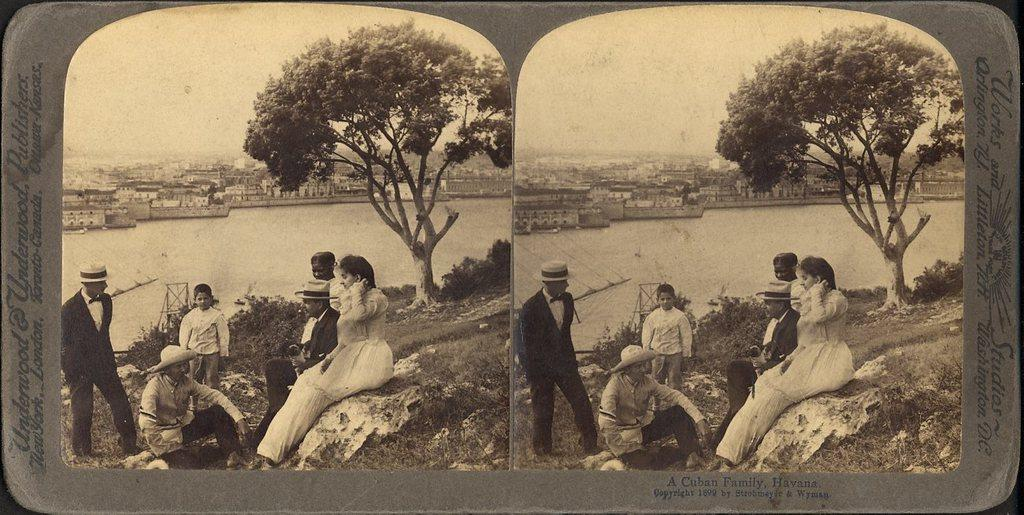Who or what is present in the image? There are people in the image. What can be seen in the image besides the people? There is water visible in the image. What is visible in the background of the image? There are trees in the background of the image. What type of plants can be seen in the stomach of the person in the image? There are no plants visible in the stomach of any person in the image. 